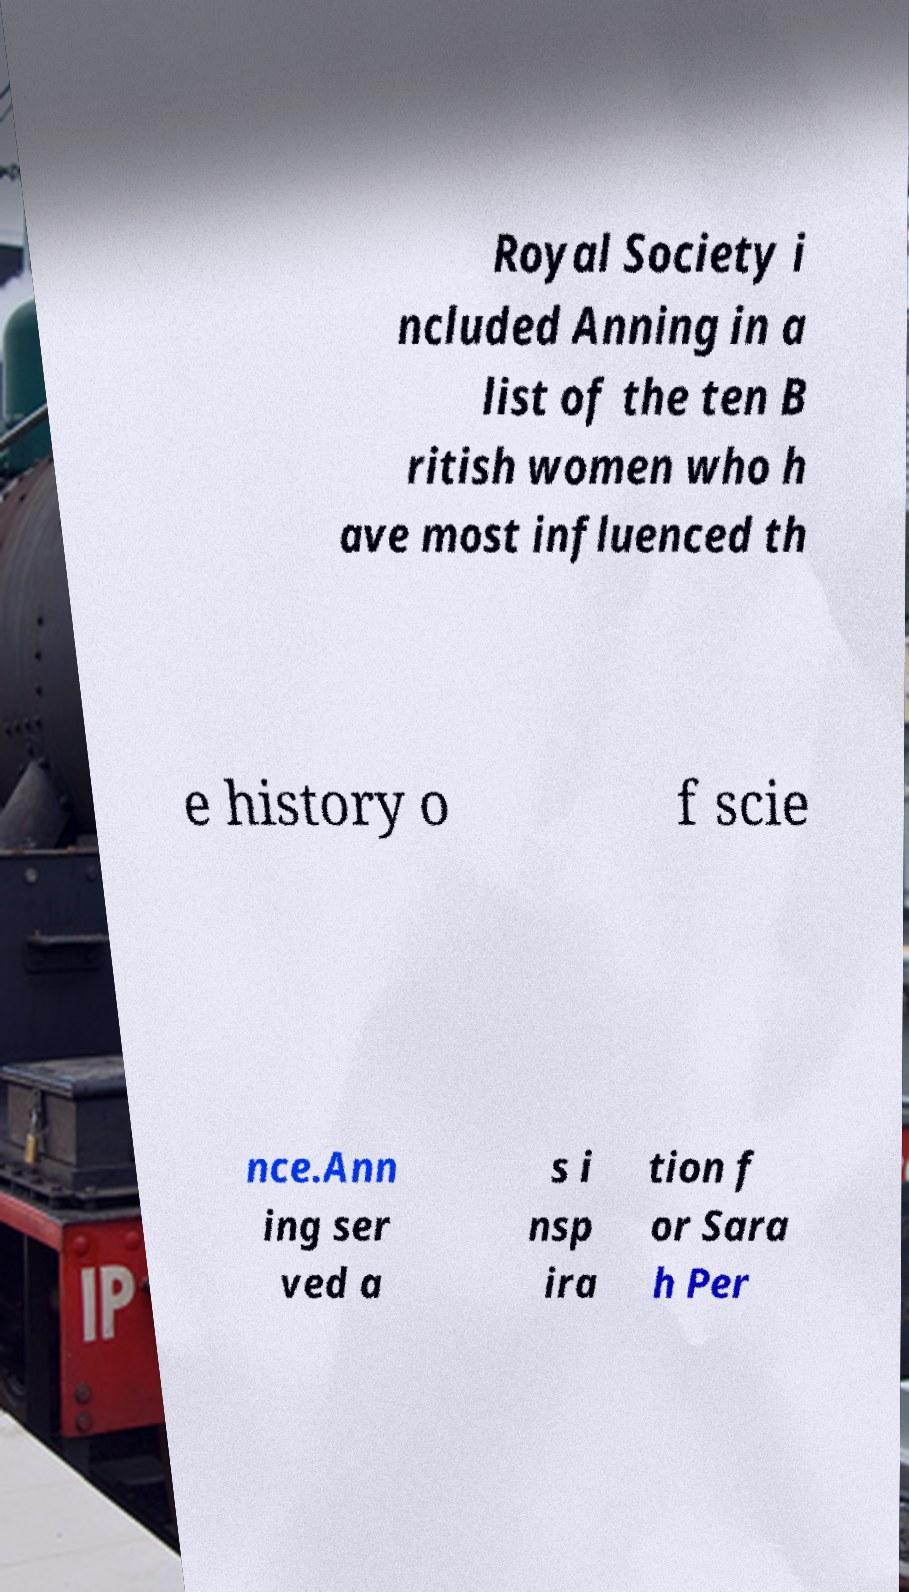Please identify and transcribe the text found in this image. Royal Society i ncluded Anning in a list of the ten B ritish women who h ave most influenced th e history o f scie nce.Ann ing ser ved a s i nsp ira tion f or Sara h Per 